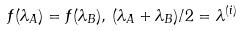<formula> <loc_0><loc_0><loc_500><loc_500>f ( \lambda _ { A } ) = f ( \lambda _ { B } ) , \, ( \lambda _ { A } + \lambda _ { B } ) / 2 = \lambda ^ { ( i ) }</formula> 